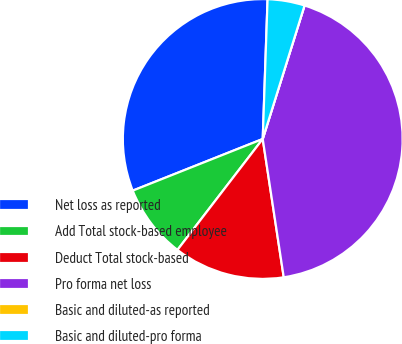Convert chart. <chart><loc_0><loc_0><loc_500><loc_500><pie_chart><fcel>Net loss as reported<fcel>Add Total stock-based employee<fcel>Deduct Total stock-based<fcel>Pro forma net loss<fcel>Basic and diluted-as reported<fcel>Basic and diluted-pro forma<nl><fcel>31.57%<fcel>8.55%<fcel>12.83%<fcel>42.77%<fcel>0.0%<fcel>4.28%<nl></chart> 